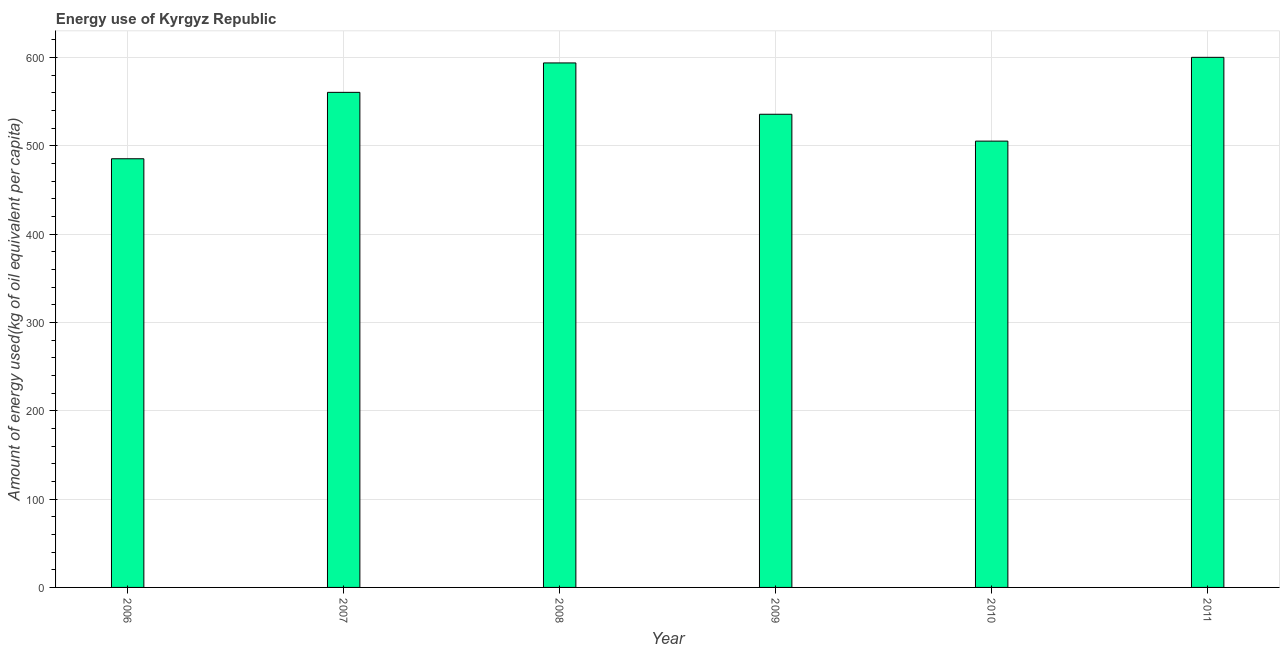What is the title of the graph?
Offer a very short reply. Energy use of Kyrgyz Republic. What is the label or title of the Y-axis?
Give a very brief answer. Amount of energy used(kg of oil equivalent per capita). What is the amount of energy used in 2008?
Ensure brevity in your answer.  593.95. Across all years, what is the maximum amount of energy used?
Give a very brief answer. 600.29. Across all years, what is the minimum amount of energy used?
Your response must be concise. 485.42. In which year was the amount of energy used minimum?
Offer a terse response. 2006. What is the sum of the amount of energy used?
Keep it short and to the point. 3281.49. What is the difference between the amount of energy used in 2008 and 2010?
Provide a short and direct response. 88.54. What is the average amount of energy used per year?
Provide a short and direct response. 546.91. What is the median amount of energy used?
Offer a terse response. 548.22. In how many years, is the amount of energy used greater than 240 kg?
Offer a terse response. 6. Do a majority of the years between 2011 and 2007 (inclusive) have amount of energy used greater than 460 kg?
Provide a short and direct response. Yes. What is the ratio of the amount of energy used in 2008 to that in 2010?
Make the answer very short. 1.18. Is the amount of energy used in 2007 less than that in 2010?
Give a very brief answer. No. What is the difference between the highest and the second highest amount of energy used?
Offer a terse response. 6.34. What is the difference between the highest and the lowest amount of energy used?
Your answer should be very brief. 114.87. In how many years, is the amount of energy used greater than the average amount of energy used taken over all years?
Offer a very short reply. 3. How many bars are there?
Your response must be concise. 6. Are all the bars in the graph horizontal?
Make the answer very short. No. How many years are there in the graph?
Your response must be concise. 6. What is the difference between two consecutive major ticks on the Y-axis?
Your answer should be compact. 100. Are the values on the major ticks of Y-axis written in scientific E-notation?
Offer a terse response. No. What is the Amount of energy used(kg of oil equivalent per capita) in 2006?
Your answer should be compact. 485.42. What is the Amount of energy used(kg of oil equivalent per capita) of 2007?
Give a very brief answer. 560.62. What is the Amount of energy used(kg of oil equivalent per capita) in 2008?
Your response must be concise. 593.95. What is the Amount of energy used(kg of oil equivalent per capita) of 2009?
Make the answer very short. 535.82. What is the Amount of energy used(kg of oil equivalent per capita) of 2010?
Provide a short and direct response. 505.4. What is the Amount of energy used(kg of oil equivalent per capita) in 2011?
Offer a terse response. 600.29. What is the difference between the Amount of energy used(kg of oil equivalent per capita) in 2006 and 2007?
Offer a terse response. -75.2. What is the difference between the Amount of energy used(kg of oil equivalent per capita) in 2006 and 2008?
Keep it short and to the point. -108.53. What is the difference between the Amount of energy used(kg of oil equivalent per capita) in 2006 and 2009?
Give a very brief answer. -50.4. What is the difference between the Amount of energy used(kg of oil equivalent per capita) in 2006 and 2010?
Provide a short and direct response. -19.98. What is the difference between the Amount of energy used(kg of oil equivalent per capita) in 2006 and 2011?
Give a very brief answer. -114.87. What is the difference between the Amount of energy used(kg of oil equivalent per capita) in 2007 and 2008?
Give a very brief answer. -33.33. What is the difference between the Amount of energy used(kg of oil equivalent per capita) in 2007 and 2009?
Provide a succinct answer. 24.8. What is the difference between the Amount of energy used(kg of oil equivalent per capita) in 2007 and 2010?
Provide a succinct answer. 55.22. What is the difference between the Amount of energy used(kg of oil equivalent per capita) in 2007 and 2011?
Ensure brevity in your answer.  -39.67. What is the difference between the Amount of energy used(kg of oil equivalent per capita) in 2008 and 2009?
Offer a terse response. 58.13. What is the difference between the Amount of energy used(kg of oil equivalent per capita) in 2008 and 2010?
Offer a very short reply. 88.54. What is the difference between the Amount of energy used(kg of oil equivalent per capita) in 2008 and 2011?
Offer a terse response. -6.34. What is the difference between the Amount of energy used(kg of oil equivalent per capita) in 2009 and 2010?
Your response must be concise. 30.41. What is the difference between the Amount of energy used(kg of oil equivalent per capita) in 2009 and 2011?
Provide a short and direct response. -64.47. What is the difference between the Amount of energy used(kg of oil equivalent per capita) in 2010 and 2011?
Ensure brevity in your answer.  -94.88. What is the ratio of the Amount of energy used(kg of oil equivalent per capita) in 2006 to that in 2007?
Make the answer very short. 0.87. What is the ratio of the Amount of energy used(kg of oil equivalent per capita) in 2006 to that in 2008?
Offer a very short reply. 0.82. What is the ratio of the Amount of energy used(kg of oil equivalent per capita) in 2006 to that in 2009?
Offer a terse response. 0.91. What is the ratio of the Amount of energy used(kg of oil equivalent per capita) in 2006 to that in 2010?
Your answer should be compact. 0.96. What is the ratio of the Amount of energy used(kg of oil equivalent per capita) in 2006 to that in 2011?
Give a very brief answer. 0.81. What is the ratio of the Amount of energy used(kg of oil equivalent per capita) in 2007 to that in 2008?
Keep it short and to the point. 0.94. What is the ratio of the Amount of energy used(kg of oil equivalent per capita) in 2007 to that in 2009?
Provide a succinct answer. 1.05. What is the ratio of the Amount of energy used(kg of oil equivalent per capita) in 2007 to that in 2010?
Provide a succinct answer. 1.11. What is the ratio of the Amount of energy used(kg of oil equivalent per capita) in 2007 to that in 2011?
Your response must be concise. 0.93. What is the ratio of the Amount of energy used(kg of oil equivalent per capita) in 2008 to that in 2009?
Give a very brief answer. 1.11. What is the ratio of the Amount of energy used(kg of oil equivalent per capita) in 2008 to that in 2010?
Offer a terse response. 1.18. What is the ratio of the Amount of energy used(kg of oil equivalent per capita) in 2008 to that in 2011?
Provide a succinct answer. 0.99. What is the ratio of the Amount of energy used(kg of oil equivalent per capita) in 2009 to that in 2010?
Your answer should be compact. 1.06. What is the ratio of the Amount of energy used(kg of oil equivalent per capita) in 2009 to that in 2011?
Ensure brevity in your answer.  0.89. What is the ratio of the Amount of energy used(kg of oil equivalent per capita) in 2010 to that in 2011?
Provide a succinct answer. 0.84. 